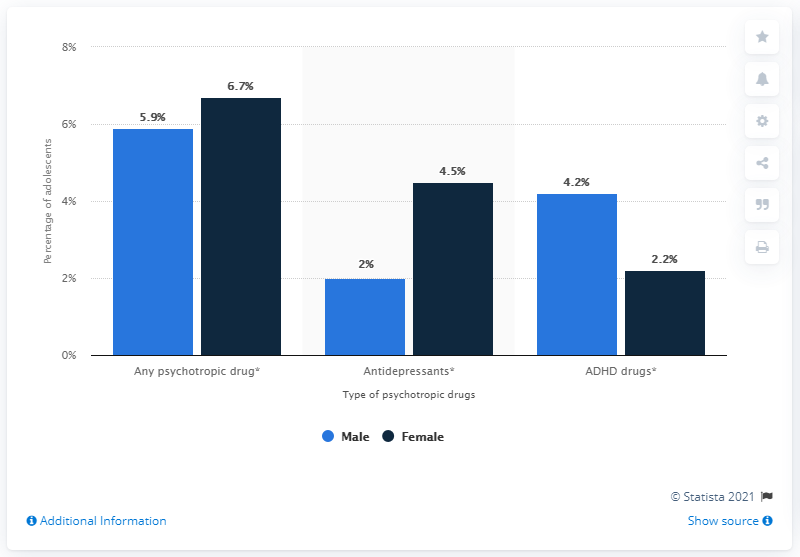List a handful of essential elements in this visual. The use of ADHD drugs by females is the highest among all genders. A drug with a difference of 0.8% between male and female genders is psychotropic, according to a study. 